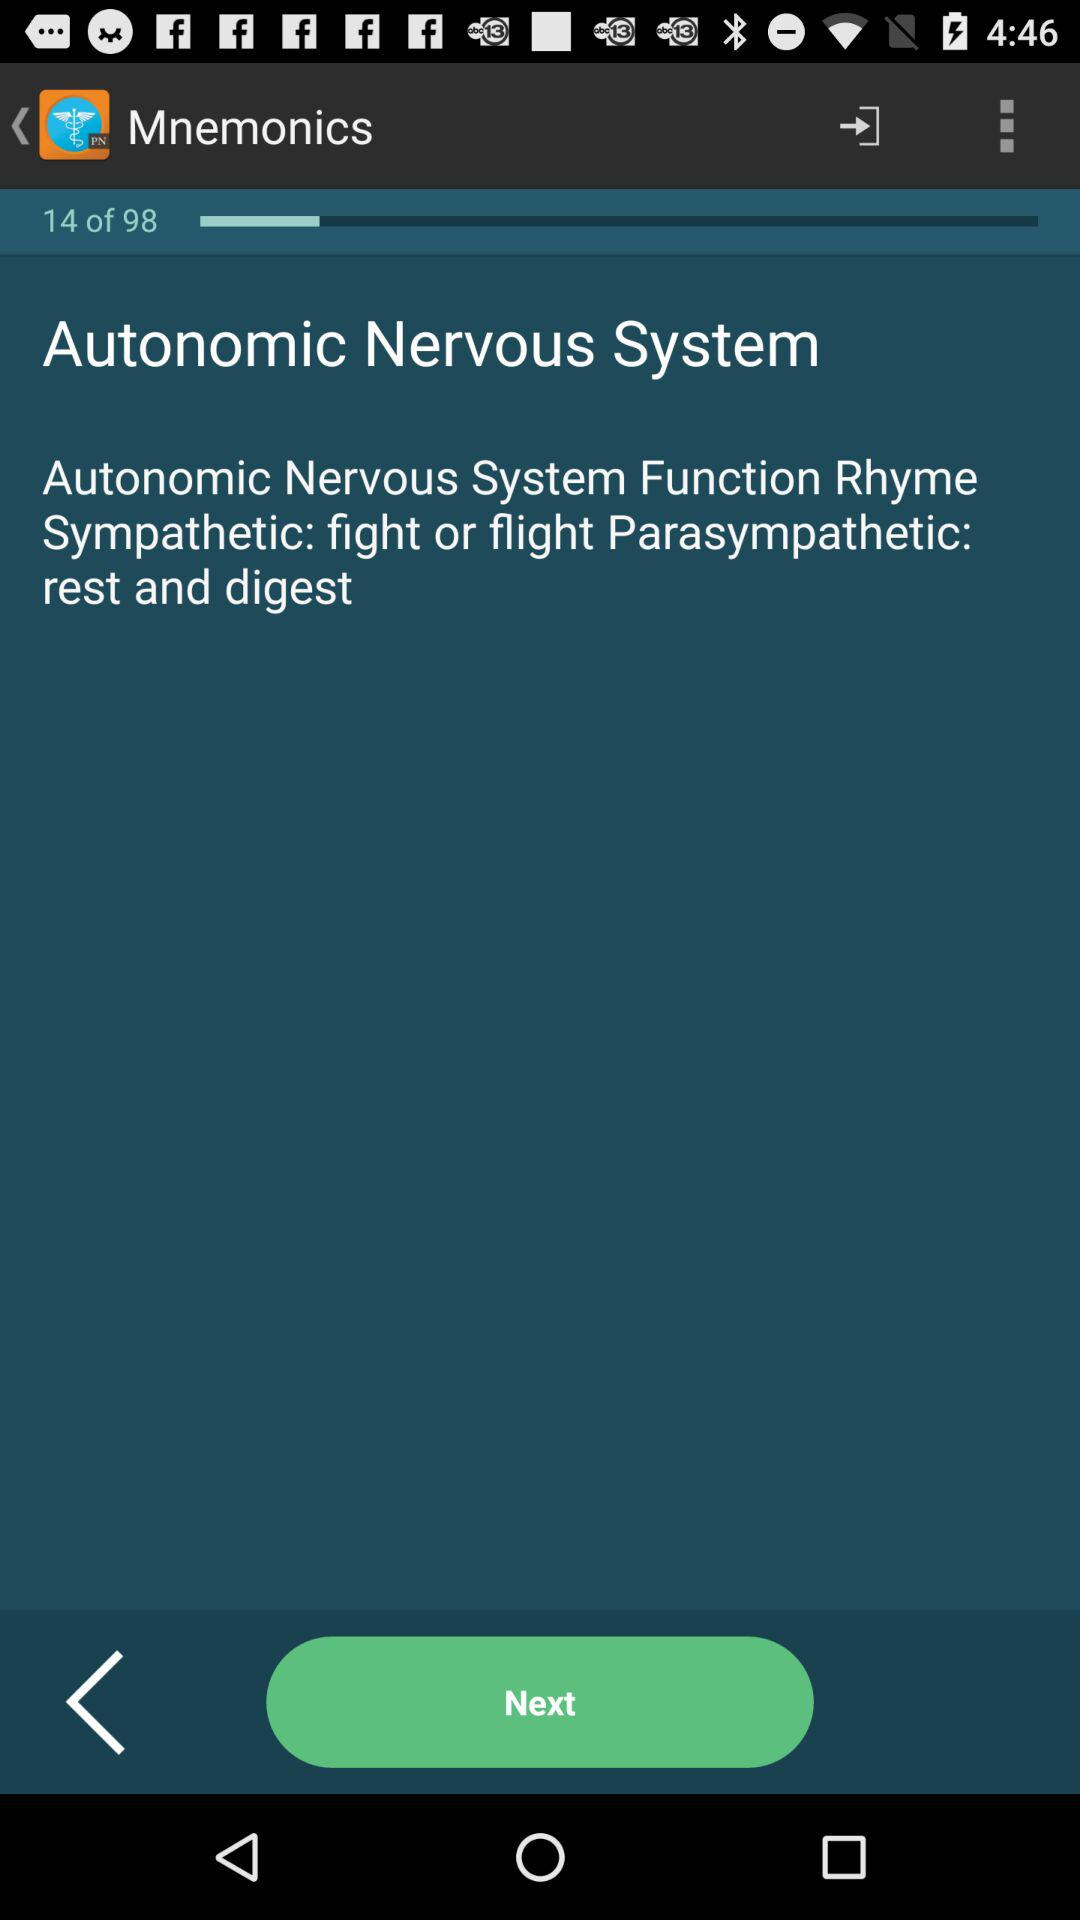How many slides in total are there? There are 98 slides. 